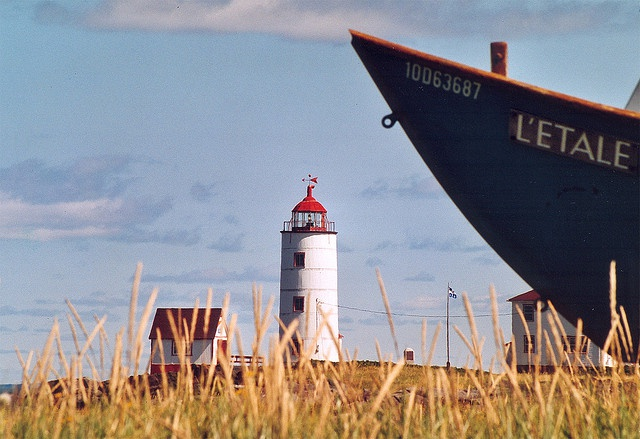Describe the objects in this image and their specific colors. I can see a boat in darkgray, black, gray, maroon, and brown tones in this image. 